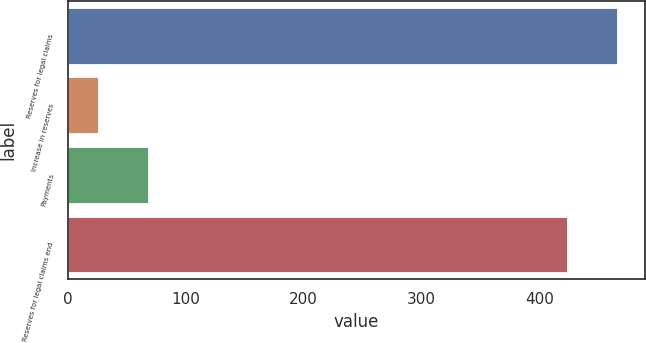Convert chart. <chart><loc_0><loc_0><loc_500><loc_500><bar_chart><fcel>Reserves for legal claims<fcel>Increase in reserves<fcel>Payments<fcel>Reserves for legal claims end<nl><fcel>466.06<fcel>25.4<fcel>67.96<fcel>423.5<nl></chart> 